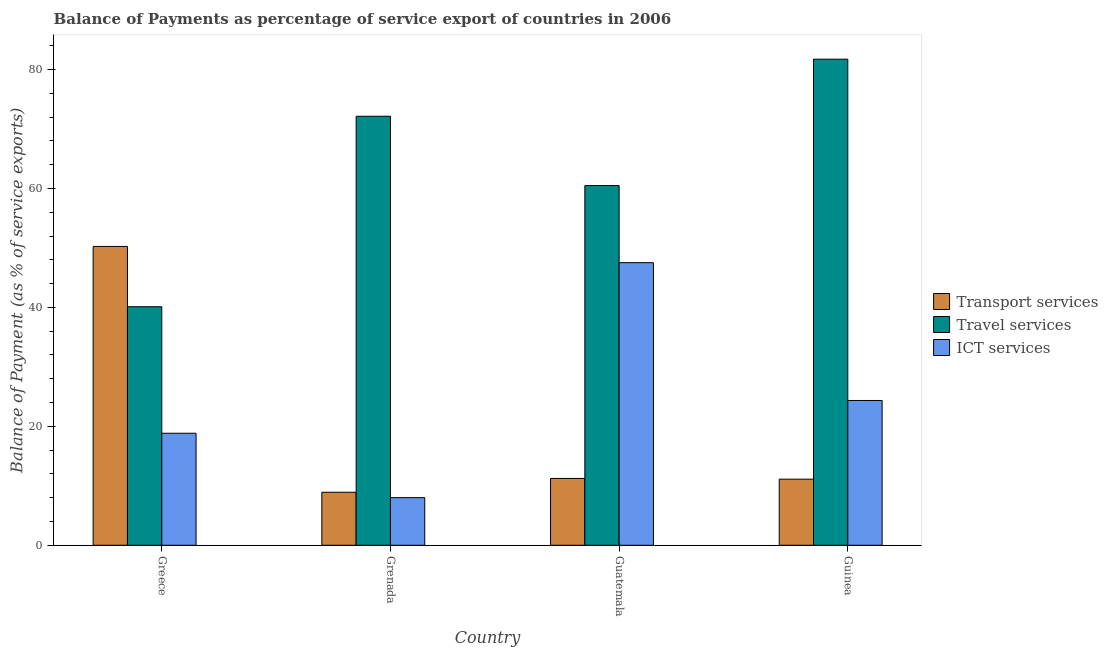How many different coloured bars are there?
Provide a succinct answer. 3. How many groups of bars are there?
Keep it short and to the point. 4. Are the number of bars on each tick of the X-axis equal?
Offer a terse response. Yes. How many bars are there on the 3rd tick from the left?
Ensure brevity in your answer.  3. How many bars are there on the 4th tick from the right?
Provide a short and direct response. 3. What is the label of the 2nd group of bars from the left?
Your answer should be very brief. Grenada. In how many cases, is the number of bars for a given country not equal to the number of legend labels?
Offer a terse response. 0. What is the balance of payment of travel services in Guatemala?
Your response must be concise. 60.48. Across all countries, what is the maximum balance of payment of travel services?
Keep it short and to the point. 81.74. Across all countries, what is the minimum balance of payment of ict services?
Offer a very short reply. 8.01. In which country was the balance of payment of travel services maximum?
Offer a very short reply. Guinea. In which country was the balance of payment of transport services minimum?
Your answer should be compact. Grenada. What is the total balance of payment of travel services in the graph?
Keep it short and to the point. 254.49. What is the difference between the balance of payment of ict services in Greece and that in Guinea?
Offer a terse response. -5.51. What is the difference between the balance of payment of ict services in Greece and the balance of payment of travel services in Guinea?
Give a very brief answer. -62.9. What is the average balance of payment of ict services per country?
Ensure brevity in your answer.  24.68. What is the difference between the balance of payment of ict services and balance of payment of transport services in Guinea?
Your answer should be very brief. 13.23. What is the ratio of the balance of payment of travel services in Greece to that in Grenada?
Keep it short and to the point. 0.56. Is the balance of payment of travel services in Greece less than that in Guinea?
Keep it short and to the point. Yes. Is the difference between the balance of payment of travel services in Guatemala and Guinea greater than the difference between the balance of payment of transport services in Guatemala and Guinea?
Offer a terse response. No. What is the difference between the highest and the second highest balance of payment of travel services?
Give a very brief answer. 9.6. What is the difference between the highest and the lowest balance of payment of travel services?
Your answer should be very brief. 41.63. In how many countries, is the balance of payment of ict services greater than the average balance of payment of ict services taken over all countries?
Offer a very short reply. 1. Is the sum of the balance of payment of travel services in Greece and Guatemala greater than the maximum balance of payment of ict services across all countries?
Your response must be concise. Yes. What does the 3rd bar from the left in Guinea represents?
Provide a succinct answer. ICT services. What does the 3rd bar from the right in Guinea represents?
Offer a very short reply. Transport services. Are all the bars in the graph horizontal?
Ensure brevity in your answer.  No. How many countries are there in the graph?
Offer a very short reply. 4. Are the values on the major ticks of Y-axis written in scientific E-notation?
Offer a very short reply. No. How many legend labels are there?
Your answer should be very brief. 3. What is the title of the graph?
Your response must be concise. Balance of Payments as percentage of service export of countries in 2006. Does "Ages 20-60" appear as one of the legend labels in the graph?
Your answer should be very brief. No. What is the label or title of the X-axis?
Provide a short and direct response. Country. What is the label or title of the Y-axis?
Provide a succinct answer. Balance of Payment (as % of service exports). What is the Balance of Payment (as % of service exports) in Transport services in Greece?
Make the answer very short. 50.25. What is the Balance of Payment (as % of service exports) of Travel services in Greece?
Your answer should be compact. 40.11. What is the Balance of Payment (as % of service exports) in ICT services in Greece?
Your response must be concise. 18.84. What is the Balance of Payment (as % of service exports) of Transport services in Grenada?
Provide a short and direct response. 8.92. What is the Balance of Payment (as % of service exports) of Travel services in Grenada?
Your response must be concise. 72.14. What is the Balance of Payment (as % of service exports) in ICT services in Grenada?
Your answer should be very brief. 8.01. What is the Balance of Payment (as % of service exports) of Transport services in Guatemala?
Keep it short and to the point. 11.24. What is the Balance of Payment (as % of service exports) of Travel services in Guatemala?
Make the answer very short. 60.48. What is the Balance of Payment (as % of service exports) in ICT services in Guatemala?
Your response must be concise. 47.52. What is the Balance of Payment (as % of service exports) in Transport services in Guinea?
Keep it short and to the point. 11.12. What is the Balance of Payment (as % of service exports) of Travel services in Guinea?
Your response must be concise. 81.74. What is the Balance of Payment (as % of service exports) in ICT services in Guinea?
Provide a short and direct response. 24.35. Across all countries, what is the maximum Balance of Payment (as % of service exports) of Transport services?
Provide a short and direct response. 50.25. Across all countries, what is the maximum Balance of Payment (as % of service exports) in Travel services?
Your answer should be compact. 81.74. Across all countries, what is the maximum Balance of Payment (as % of service exports) in ICT services?
Give a very brief answer. 47.52. Across all countries, what is the minimum Balance of Payment (as % of service exports) of Transport services?
Offer a very short reply. 8.92. Across all countries, what is the minimum Balance of Payment (as % of service exports) in Travel services?
Ensure brevity in your answer.  40.11. Across all countries, what is the minimum Balance of Payment (as % of service exports) in ICT services?
Your response must be concise. 8.01. What is the total Balance of Payment (as % of service exports) of Transport services in the graph?
Give a very brief answer. 81.52. What is the total Balance of Payment (as % of service exports) of Travel services in the graph?
Ensure brevity in your answer.  254.49. What is the total Balance of Payment (as % of service exports) in ICT services in the graph?
Offer a terse response. 98.72. What is the difference between the Balance of Payment (as % of service exports) in Transport services in Greece and that in Grenada?
Make the answer very short. 41.34. What is the difference between the Balance of Payment (as % of service exports) of Travel services in Greece and that in Grenada?
Make the answer very short. -32.03. What is the difference between the Balance of Payment (as % of service exports) of ICT services in Greece and that in Grenada?
Offer a very short reply. 10.83. What is the difference between the Balance of Payment (as % of service exports) of Transport services in Greece and that in Guatemala?
Your answer should be very brief. 39.02. What is the difference between the Balance of Payment (as % of service exports) of Travel services in Greece and that in Guatemala?
Offer a very short reply. -20.37. What is the difference between the Balance of Payment (as % of service exports) in ICT services in Greece and that in Guatemala?
Your answer should be very brief. -28.68. What is the difference between the Balance of Payment (as % of service exports) in Transport services in Greece and that in Guinea?
Your answer should be very brief. 39.14. What is the difference between the Balance of Payment (as % of service exports) in Travel services in Greece and that in Guinea?
Offer a terse response. -41.63. What is the difference between the Balance of Payment (as % of service exports) in ICT services in Greece and that in Guinea?
Offer a terse response. -5.51. What is the difference between the Balance of Payment (as % of service exports) in Transport services in Grenada and that in Guatemala?
Offer a very short reply. -2.32. What is the difference between the Balance of Payment (as % of service exports) of Travel services in Grenada and that in Guatemala?
Give a very brief answer. 11.66. What is the difference between the Balance of Payment (as % of service exports) of ICT services in Grenada and that in Guatemala?
Keep it short and to the point. -39.51. What is the difference between the Balance of Payment (as % of service exports) of Transport services in Grenada and that in Guinea?
Keep it short and to the point. -2.2. What is the difference between the Balance of Payment (as % of service exports) of Travel services in Grenada and that in Guinea?
Your response must be concise. -9.6. What is the difference between the Balance of Payment (as % of service exports) in ICT services in Grenada and that in Guinea?
Your response must be concise. -16.34. What is the difference between the Balance of Payment (as % of service exports) of Transport services in Guatemala and that in Guinea?
Give a very brief answer. 0.12. What is the difference between the Balance of Payment (as % of service exports) in Travel services in Guatemala and that in Guinea?
Give a very brief answer. -21.26. What is the difference between the Balance of Payment (as % of service exports) of ICT services in Guatemala and that in Guinea?
Your answer should be very brief. 23.17. What is the difference between the Balance of Payment (as % of service exports) in Transport services in Greece and the Balance of Payment (as % of service exports) in Travel services in Grenada?
Keep it short and to the point. -21.89. What is the difference between the Balance of Payment (as % of service exports) of Transport services in Greece and the Balance of Payment (as % of service exports) of ICT services in Grenada?
Keep it short and to the point. 42.24. What is the difference between the Balance of Payment (as % of service exports) in Travel services in Greece and the Balance of Payment (as % of service exports) in ICT services in Grenada?
Offer a terse response. 32.1. What is the difference between the Balance of Payment (as % of service exports) of Transport services in Greece and the Balance of Payment (as % of service exports) of Travel services in Guatemala?
Give a very brief answer. -10.23. What is the difference between the Balance of Payment (as % of service exports) of Transport services in Greece and the Balance of Payment (as % of service exports) of ICT services in Guatemala?
Make the answer very short. 2.73. What is the difference between the Balance of Payment (as % of service exports) of Travel services in Greece and the Balance of Payment (as % of service exports) of ICT services in Guatemala?
Provide a succinct answer. -7.41. What is the difference between the Balance of Payment (as % of service exports) of Transport services in Greece and the Balance of Payment (as % of service exports) of Travel services in Guinea?
Provide a succinct answer. -31.49. What is the difference between the Balance of Payment (as % of service exports) of Transport services in Greece and the Balance of Payment (as % of service exports) of ICT services in Guinea?
Your answer should be compact. 25.9. What is the difference between the Balance of Payment (as % of service exports) of Travel services in Greece and the Balance of Payment (as % of service exports) of ICT services in Guinea?
Provide a succinct answer. 15.77. What is the difference between the Balance of Payment (as % of service exports) of Transport services in Grenada and the Balance of Payment (as % of service exports) of Travel services in Guatemala?
Your response must be concise. -51.57. What is the difference between the Balance of Payment (as % of service exports) in Transport services in Grenada and the Balance of Payment (as % of service exports) in ICT services in Guatemala?
Your answer should be very brief. -38.61. What is the difference between the Balance of Payment (as % of service exports) of Travel services in Grenada and the Balance of Payment (as % of service exports) of ICT services in Guatemala?
Make the answer very short. 24.62. What is the difference between the Balance of Payment (as % of service exports) in Transport services in Grenada and the Balance of Payment (as % of service exports) in Travel services in Guinea?
Provide a succinct answer. -72.83. What is the difference between the Balance of Payment (as % of service exports) of Transport services in Grenada and the Balance of Payment (as % of service exports) of ICT services in Guinea?
Your answer should be very brief. -15.43. What is the difference between the Balance of Payment (as % of service exports) of Travel services in Grenada and the Balance of Payment (as % of service exports) of ICT services in Guinea?
Provide a succinct answer. 47.8. What is the difference between the Balance of Payment (as % of service exports) of Transport services in Guatemala and the Balance of Payment (as % of service exports) of Travel services in Guinea?
Provide a succinct answer. -70.5. What is the difference between the Balance of Payment (as % of service exports) of Transport services in Guatemala and the Balance of Payment (as % of service exports) of ICT services in Guinea?
Offer a terse response. -13.11. What is the difference between the Balance of Payment (as % of service exports) in Travel services in Guatemala and the Balance of Payment (as % of service exports) in ICT services in Guinea?
Ensure brevity in your answer.  36.14. What is the average Balance of Payment (as % of service exports) of Transport services per country?
Provide a short and direct response. 20.38. What is the average Balance of Payment (as % of service exports) of Travel services per country?
Your response must be concise. 63.62. What is the average Balance of Payment (as % of service exports) in ICT services per country?
Provide a succinct answer. 24.68. What is the difference between the Balance of Payment (as % of service exports) of Transport services and Balance of Payment (as % of service exports) of Travel services in Greece?
Provide a short and direct response. 10.14. What is the difference between the Balance of Payment (as % of service exports) in Transport services and Balance of Payment (as % of service exports) in ICT services in Greece?
Offer a terse response. 31.42. What is the difference between the Balance of Payment (as % of service exports) in Travel services and Balance of Payment (as % of service exports) in ICT services in Greece?
Your answer should be compact. 21.28. What is the difference between the Balance of Payment (as % of service exports) of Transport services and Balance of Payment (as % of service exports) of Travel services in Grenada?
Offer a very short reply. -63.23. What is the difference between the Balance of Payment (as % of service exports) of Transport services and Balance of Payment (as % of service exports) of ICT services in Grenada?
Give a very brief answer. 0.9. What is the difference between the Balance of Payment (as % of service exports) in Travel services and Balance of Payment (as % of service exports) in ICT services in Grenada?
Provide a succinct answer. 64.13. What is the difference between the Balance of Payment (as % of service exports) in Transport services and Balance of Payment (as % of service exports) in Travel services in Guatemala?
Make the answer very short. -49.25. What is the difference between the Balance of Payment (as % of service exports) of Transport services and Balance of Payment (as % of service exports) of ICT services in Guatemala?
Give a very brief answer. -36.28. What is the difference between the Balance of Payment (as % of service exports) of Travel services and Balance of Payment (as % of service exports) of ICT services in Guatemala?
Offer a very short reply. 12.96. What is the difference between the Balance of Payment (as % of service exports) of Transport services and Balance of Payment (as % of service exports) of Travel services in Guinea?
Make the answer very short. -70.63. What is the difference between the Balance of Payment (as % of service exports) in Transport services and Balance of Payment (as % of service exports) in ICT services in Guinea?
Give a very brief answer. -13.23. What is the difference between the Balance of Payment (as % of service exports) in Travel services and Balance of Payment (as % of service exports) in ICT services in Guinea?
Provide a short and direct response. 57.39. What is the ratio of the Balance of Payment (as % of service exports) in Transport services in Greece to that in Grenada?
Offer a very short reply. 5.64. What is the ratio of the Balance of Payment (as % of service exports) in Travel services in Greece to that in Grenada?
Offer a very short reply. 0.56. What is the ratio of the Balance of Payment (as % of service exports) of ICT services in Greece to that in Grenada?
Offer a terse response. 2.35. What is the ratio of the Balance of Payment (as % of service exports) of Transport services in Greece to that in Guatemala?
Ensure brevity in your answer.  4.47. What is the ratio of the Balance of Payment (as % of service exports) in Travel services in Greece to that in Guatemala?
Your answer should be very brief. 0.66. What is the ratio of the Balance of Payment (as % of service exports) in ICT services in Greece to that in Guatemala?
Provide a succinct answer. 0.4. What is the ratio of the Balance of Payment (as % of service exports) of Transport services in Greece to that in Guinea?
Your answer should be very brief. 4.52. What is the ratio of the Balance of Payment (as % of service exports) of Travel services in Greece to that in Guinea?
Your response must be concise. 0.49. What is the ratio of the Balance of Payment (as % of service exports) of ICT services in Greece to that in Guinea?
Your answer should be very brief. 0.77. What is the ratio of the Balance of Payment (as % of service exports) of Transport services in Grenada to that in Guatemala?
Your response must be concise. 0.79. What is the ratio of the Balance of Payment (as % of service exports) of Travel services in Grenada to that in Guatemala?
Your answer should be very brief. 1.19. What is the ratio of the Balance of Payment (as % of service exports) of ICT services in Grenada to that in Guatemala?
Provide a succinct answer. 0.17. What is the ratio of the Balance of Payment (as % of service exports) in Transport services in Grenada to that in Guinea?
Provide a short and direct response. 0.8. What is the ratio of the Balance of Payment (as % of service exports) of Travel services in Grenada to that in Guinea?
Ensure brevity in your answer.  0.88. What is the ratio of the Balance of Payment (as % of service exports) of ICT services in Grenada to that in Guinea?
Give a very brief answer. 0.33. What is the ratio of the Balance of Payment (as % of service exports) in Travel services in Guatemala to that in Guinea?
Ensure brevity in your answer.  0.74. What is the ratio of the Balance of Payment (as % of service exports) of ICT services in Guatemala to that in Guinea?
Ensure brevity in your answer.  1.95. What is the difference between the highest and the second highest Balance of Payment (as % of service exports) of Transport services?
Provide a succinct answer. 39.02. What is the difference between the highest and the second highest Balance of Payment (as % of service exports) in Travel services?
Your answer should be compact. 9.6. What is the difference between the highest and the second highest Balance of Payment (as % of service exports) in ICT services?
Your response must be concise. 23.17. What is the difference between the highest and the lowest Balance of Payment (as % of service exports) in Transport services?
Offer a very short reply. 41.34. What is the difference between the highest and the lowest Balance of Payment (as % of service exports) of Travel services?
Your answer should be very brief. 41.63. What is the difference between the highest and the lowest Balance of Payment (as % of service exports) of ICT services?
Offer a terse response. 39.51. 